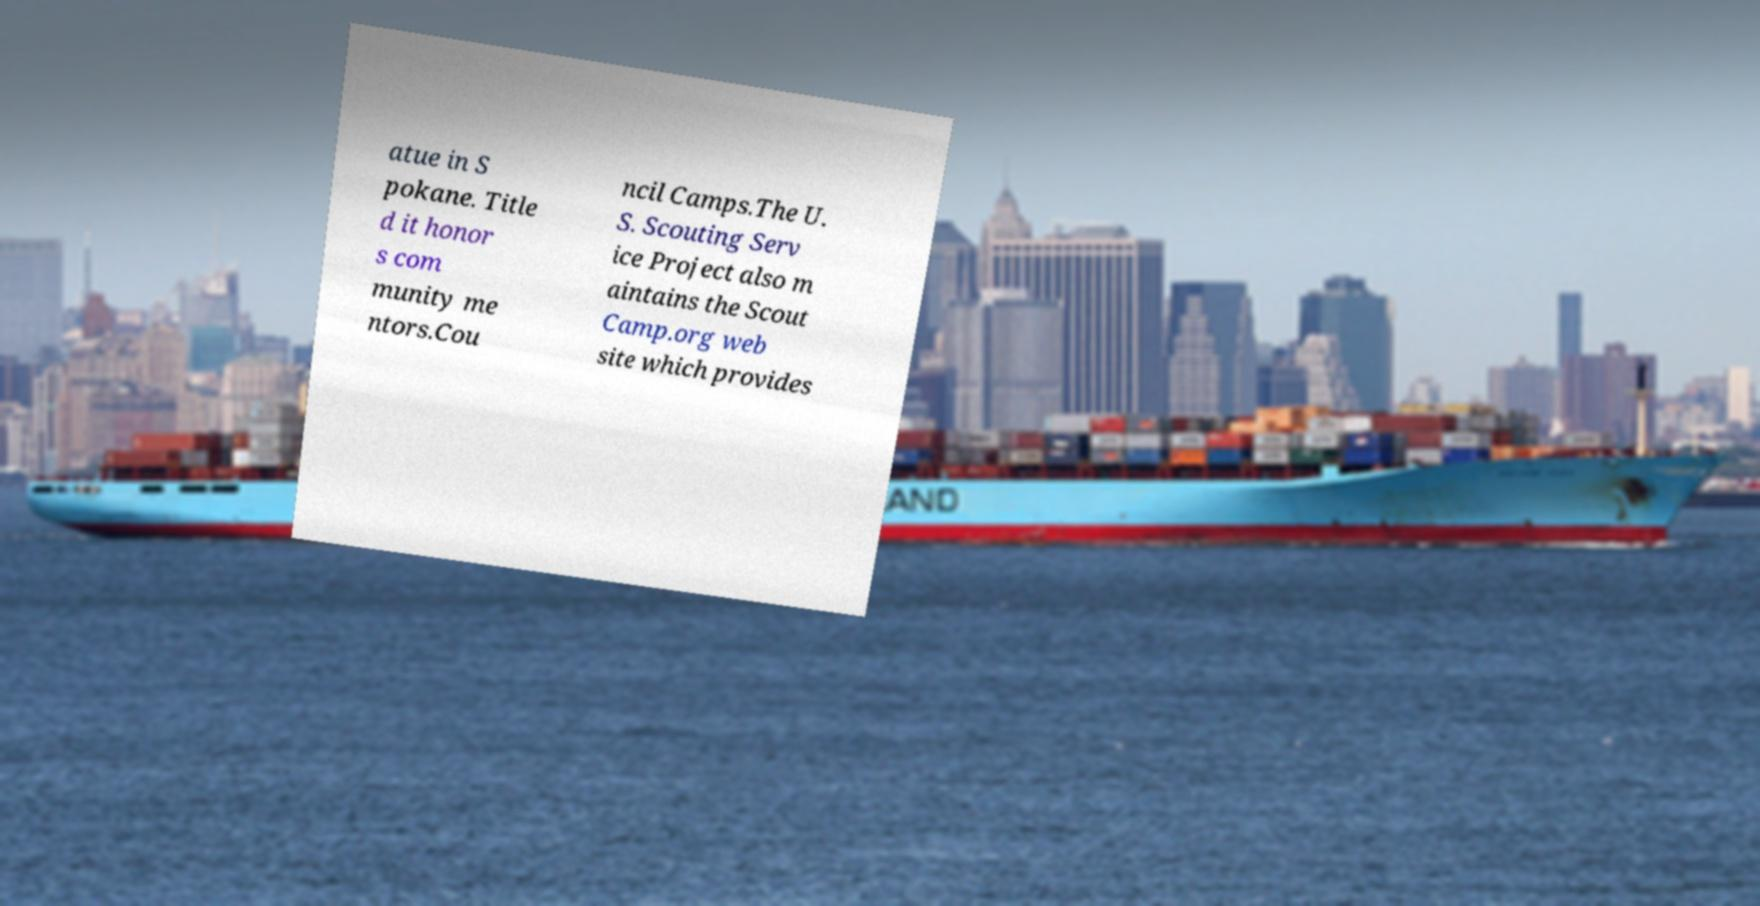Please read and relay the text visible in this image. What does it say? atue in S pokane. Title d it honor s com munity me ntors.Cou ncil Camps.The U. S. Scouting Serv ice Project also m aintains the Scout Camp.org web site which provides 